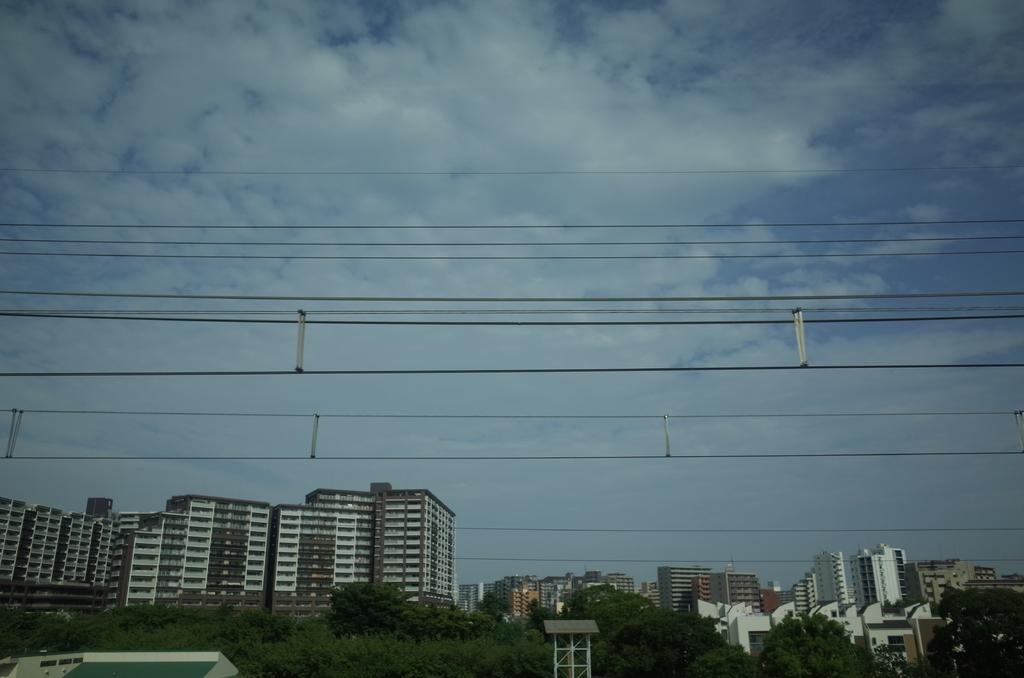What type of vegetation can be seen in the image? There are trees in the image. What is the color of the trees? The trees are green. What type of structures are present in the image? There are buildings in the image. What colors are the buildings? The buildings are white and brown. What else can be seen in the image? There are current wires in the image. What is visible in the background of the image? The sky is blue and white in the background. What type of party is being held in the image? There is no party present in the image. What is the governor doing in the image? There is no governor present in the image. 